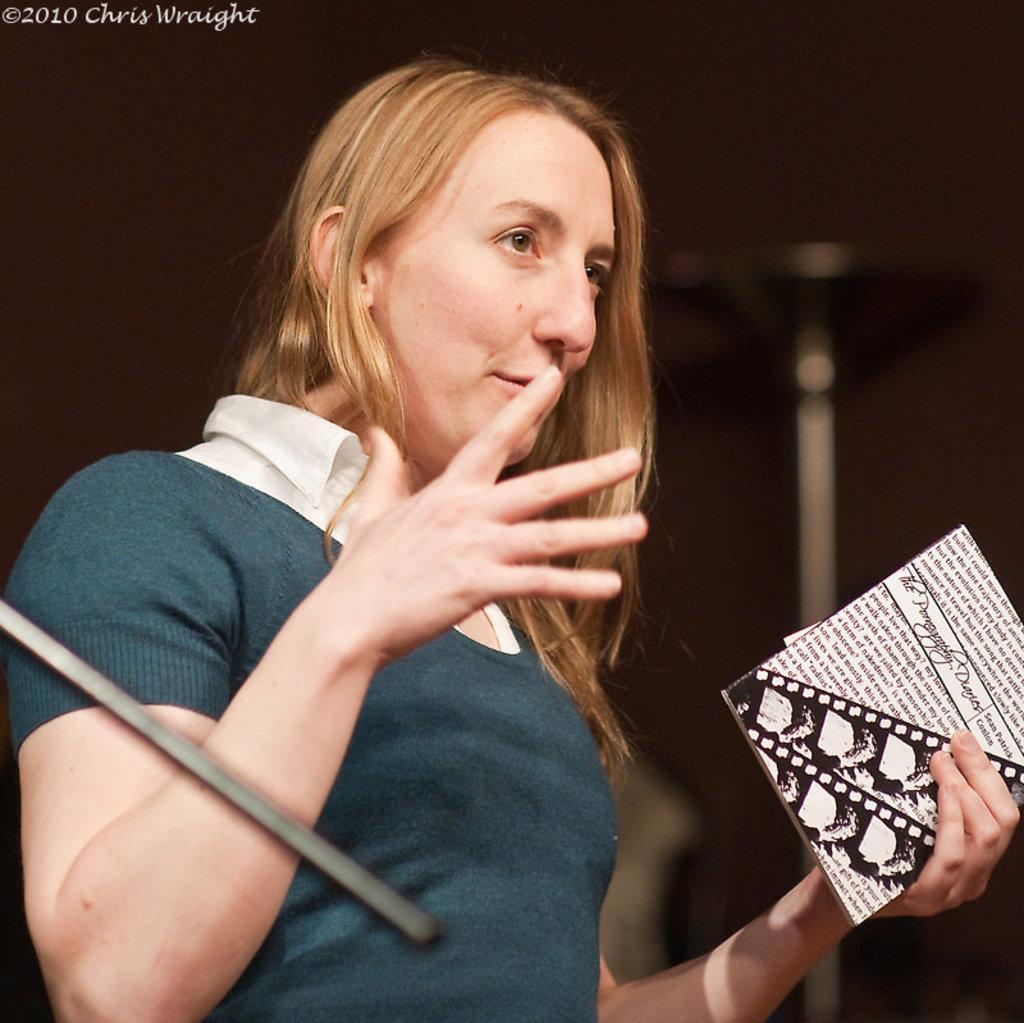Please provide a concise description of this image. In this picture we can see a woman holding a book with her hand. And there is a dark background. 